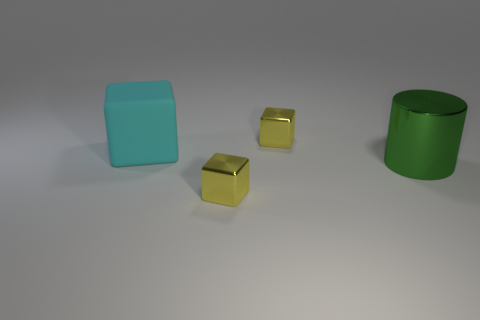Are there any other objects in the image apart from the ones already discussed? No, the image only contains the cyan object, two gold cubes, and the green cylinder. There are no other objects apart from these. 